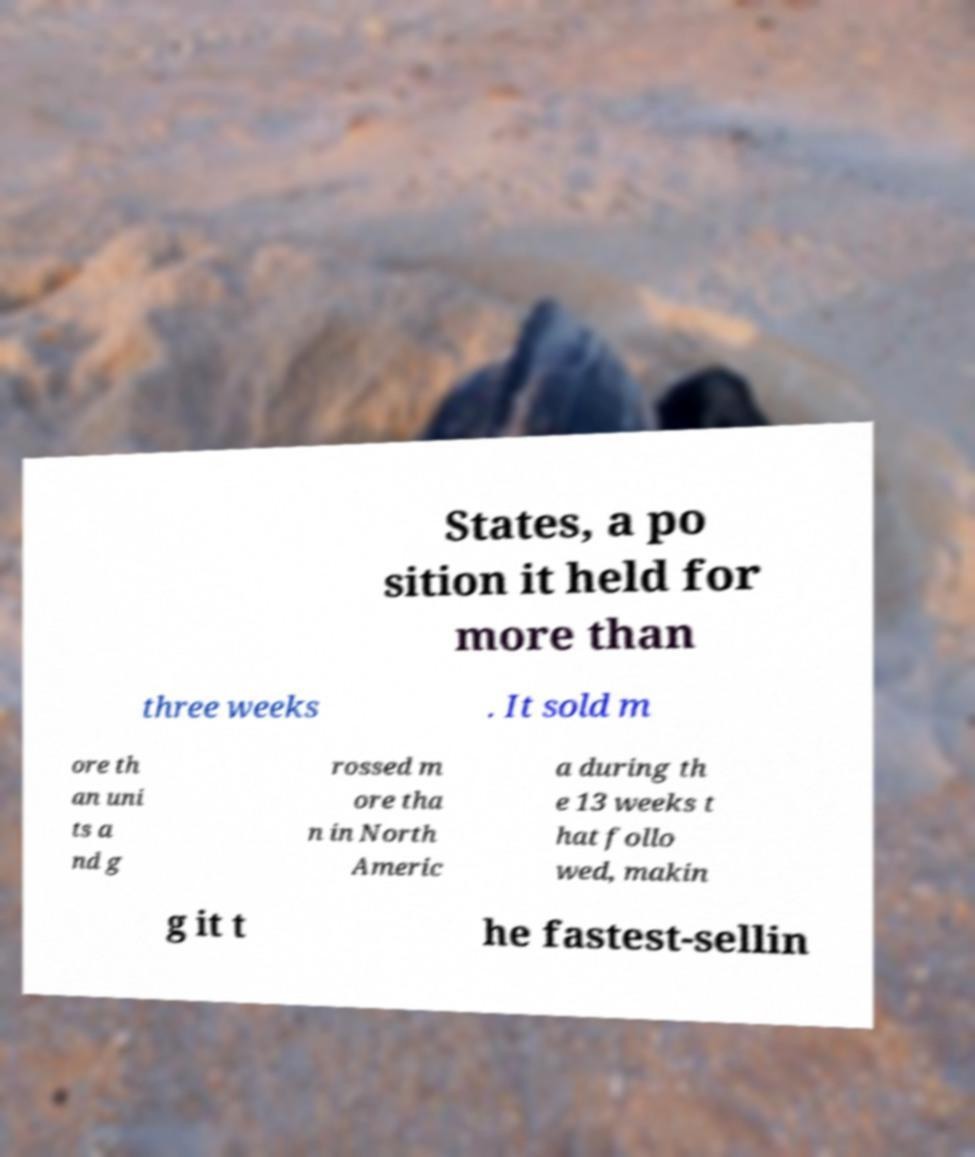Could you extract and type out the text from this image? States, a po sition it held for more than three weeks . It sold m ore th an uni ts a nd g rossed m ore tha n in North Americ a during th e 13 weeks t hat follo wed, makin g it t he fastest-sellin 